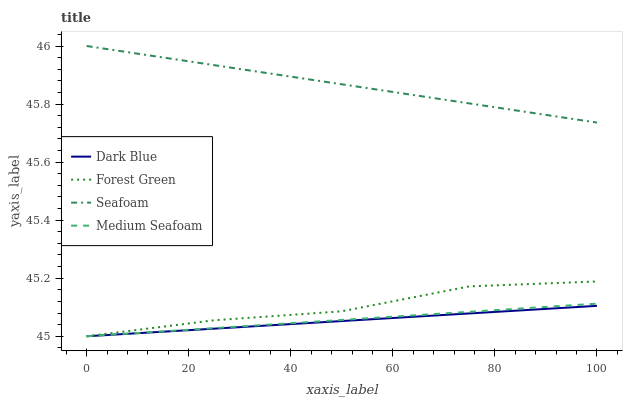Does Dark Blue have the minimum area under the curve?
Answer yes or no. Yes. Does Seafoam have the maximum area under the curve?
Answer yes or no. Yes. Does Forest Green have the minimum area under the curve?
Answer yes or no. No. Does Forest Green have the maximum area under the curve?
Answer yes or no. No. Is Dark Blue the smoothest?
Answer yes or no. Yes. Is Forest Green the roughest?
Answer yes or no. Yes. Is Seafoam the smoothest?
Answer yes or no. No. Is Seafoam the roughest?
Answer yes or no. No. Does Seafoam have the lowest value?
Answer yes or no. No. Does Seafoam have the highest value?
Answer yes or no. Yes. Does Forest Green have the highest value?
Answer yes or no. No. Is Dark Blue less than Seafoam?
Answer yes or no. Yes. Is Seafoam greater than Medium Seafoam?
Answer yes or no. Yes. Does Forest Green intersect Medium Seafoam?
Answer yes or no. Yes. Is Forest Green less than Medium Seafoam?
Answer yes or no. No. Is Forest Green greater than Medium Seafoam?
Answer yes or no. No. Does Dark Blue intersect Seafoam?
Answer yes or no. No. 